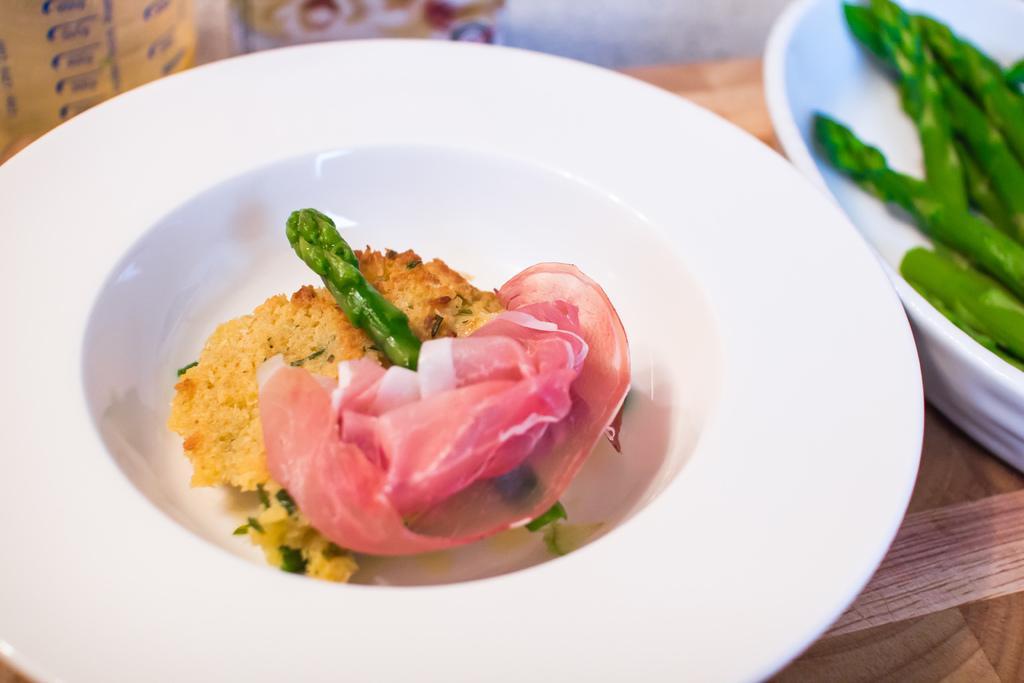In one or two sentences, can you explain what this image depicts? In this picture we can see food items in bowls and these bowls are on a wooden platform and in the background we can see some objects. 